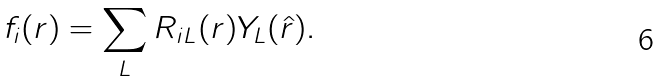<formula> <loc_0><loc_0><loc_500><loc_500>f _ { i } ( { r } ) = \sum _ { L } R _ { i L } ( r ) Y _ { L } ( \hat { r } ) .</formula> 